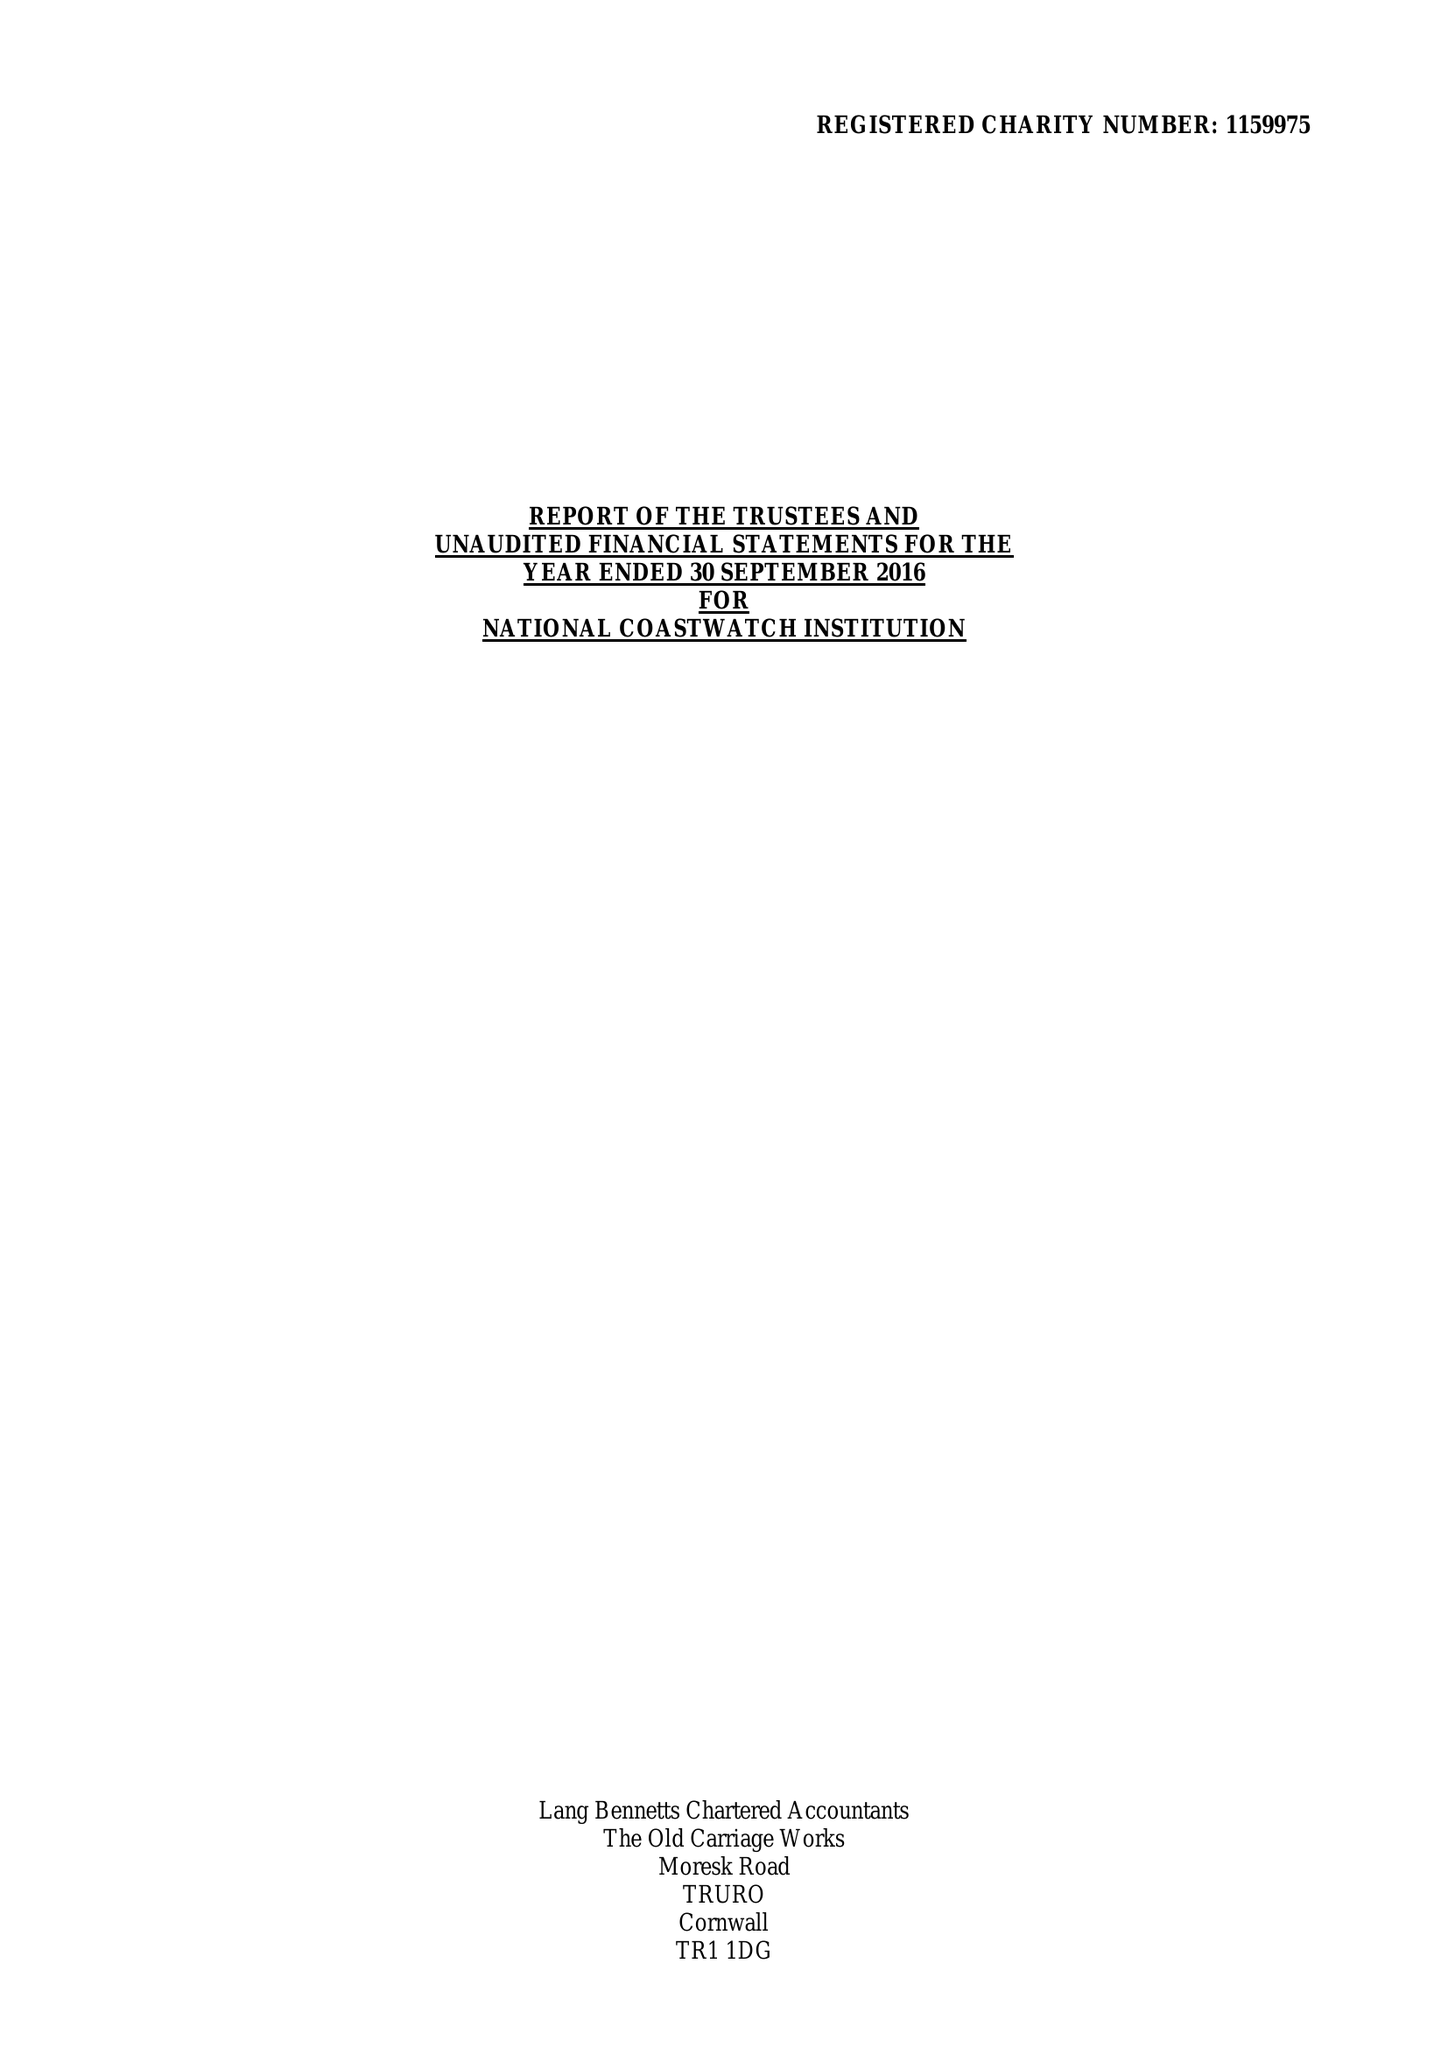What is the value for the address__street_line?
Answer the question using a single word or phrase. 17 DEAN STREET 